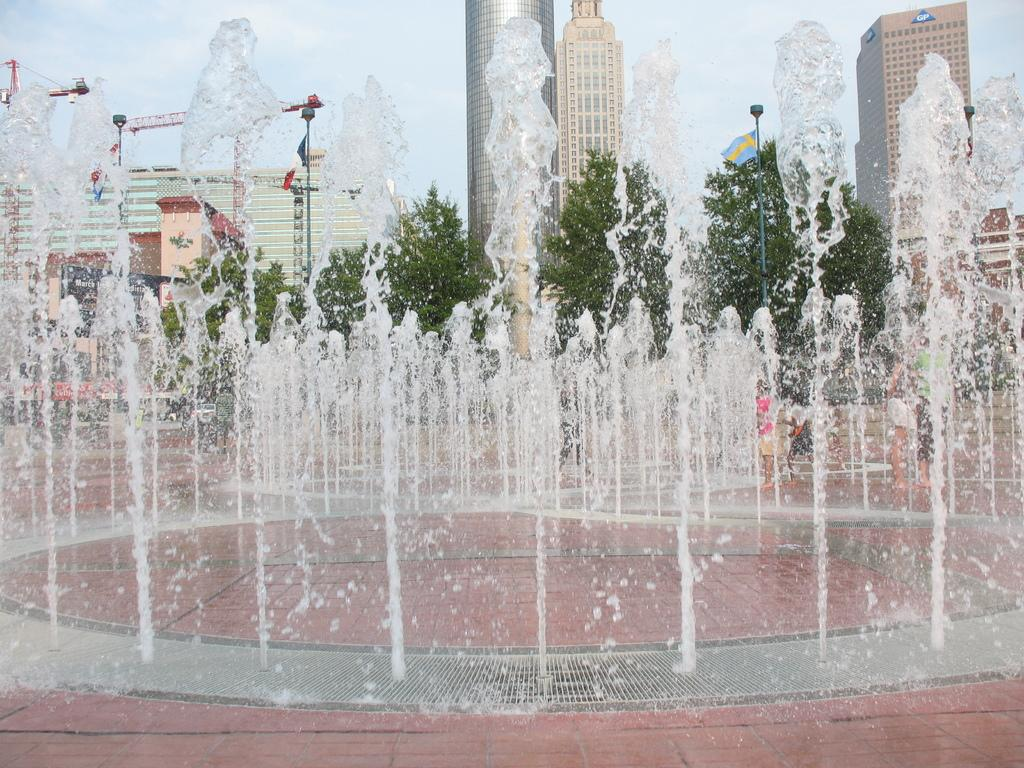What is the main feature in the picture? There is a fountain in the picture. Are there any people present in the image? Yes, there are people standing in the picture. What can be seen in the background of the picture? There are trees and buildings in the background of the picture. How would you describe the weather in the image? The sky is clear in the picture, suggesting good weather. What type of tax is being discussed by the people in the image? There is no indication in the image that the people are discussing any type of tax. 